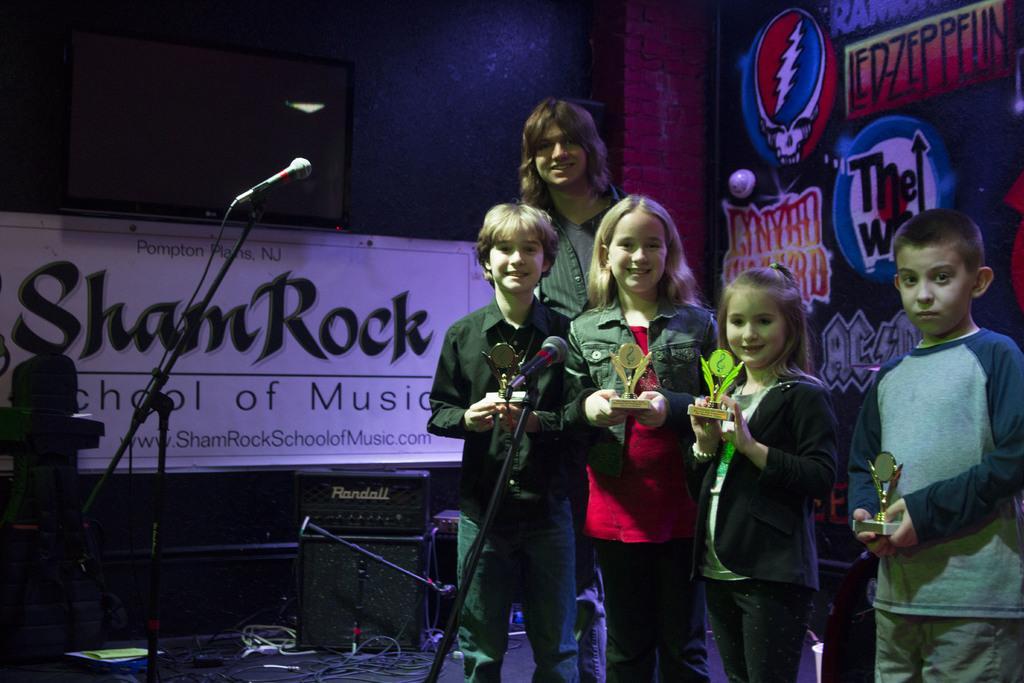Can you describe this image briefly? In this picture we can observe four children. Behind them there is a person standing. We can observe prizes in their hands. We can observe two girls and two boys. There are two mics on the floor. In the background there are speakers. We can observe a screen fixed to the wall. 